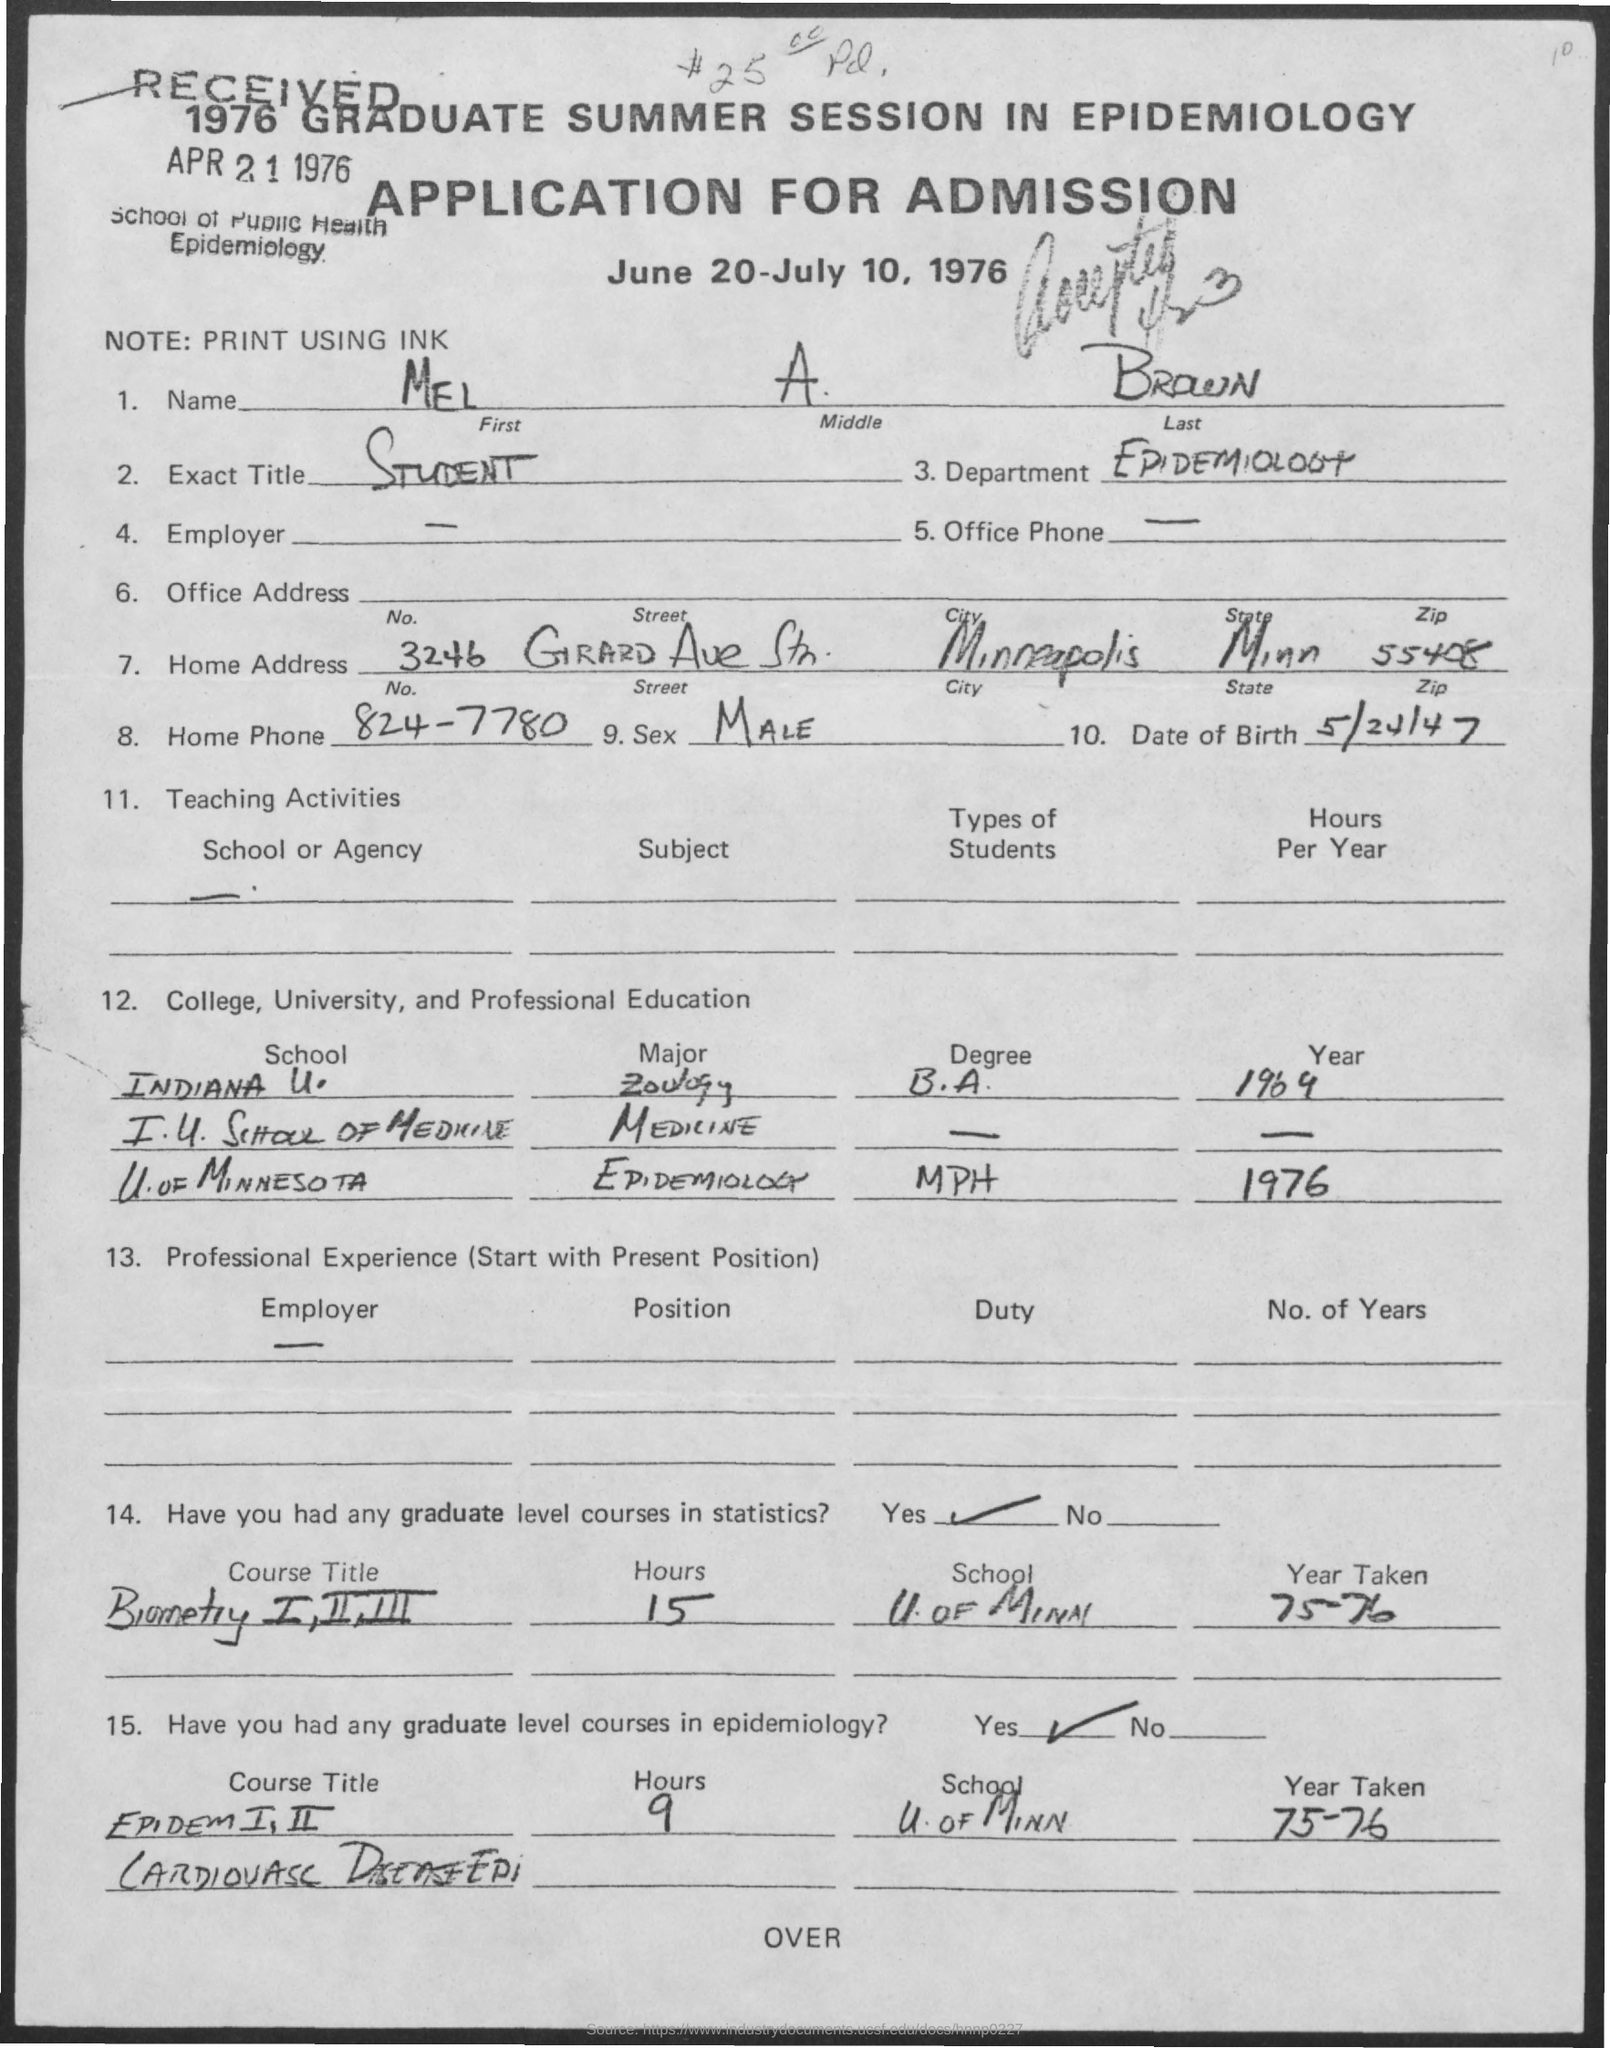Highlight a few significant elements in this photo. In 1976, Mel majored in epidemiology at the University of Minnesota. The application was received in 1976. The date of birth of Mel is May 24th, 1947. Mel is from the department of Epidemiology. The name given is MEL A BROWN. 